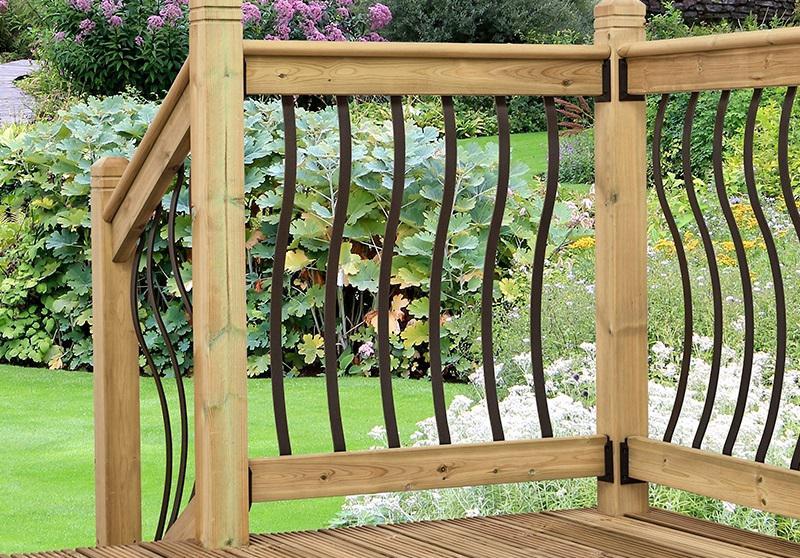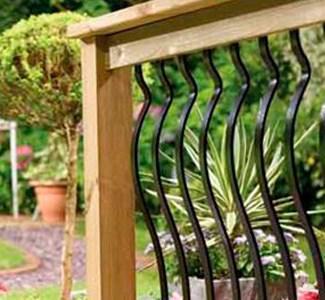The first image is the image on the left, the second image is the image on the right. For the images shown, is this caption "All the railing spindles are straight." true? Answer yes or no. No. The first image is the image on the left, the second image is the image on the right. Assess this claim about the two images: "Flowers and foliage are seen through curving black vertical rails mounted to light wood in both scenes.". Correct or not? Answer yes or no. Yes. 